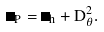<formula> <loc_0><loc_0><loc_500><loc_500>\Delta _ { P } = \Delta _ { h } + D _ { \theta } ^ { 2 } .</formula> 